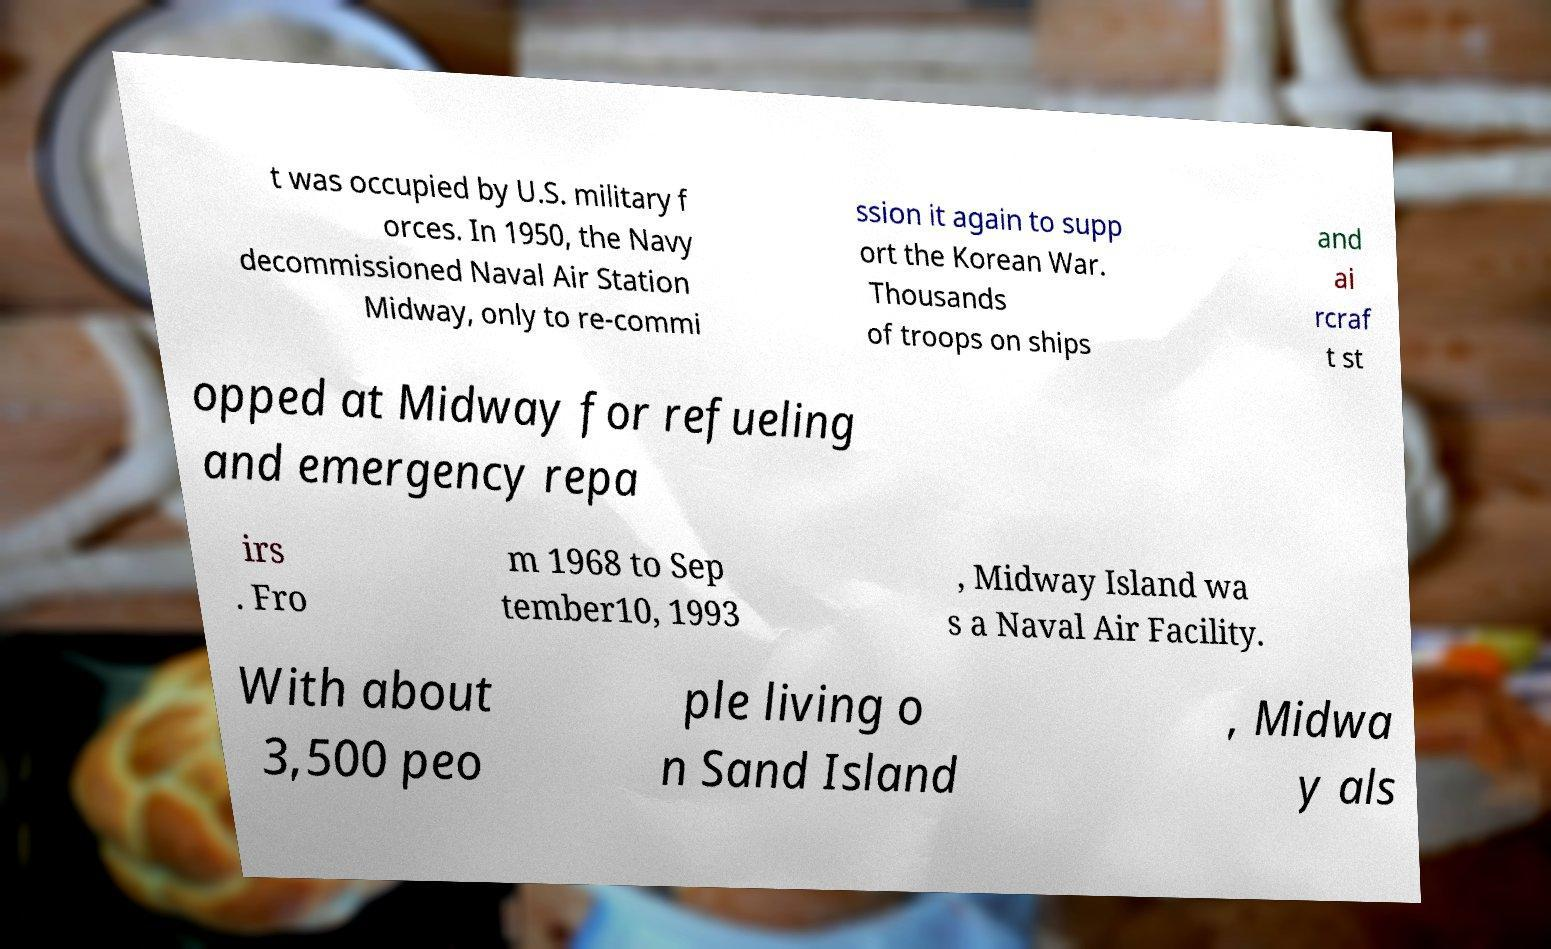For documentation purposes, I need the text within this image transcribed. Could you provide that? t was occupied by U.S. military f orces. In 1950, the Navy decommissioned Naval Air Station Midway, only to re-commi ssion it again to supp ort the Korean War. Thousands of troops on ships and ai rcraf t st opped at Midway for refueling and emergency repa irs . Fro m 1968 to Sep tember10, 1993 , Midway Island wa s a Naval Air Facility. With about 3,500 peo ple living o n Sand Island , Midwa y als 